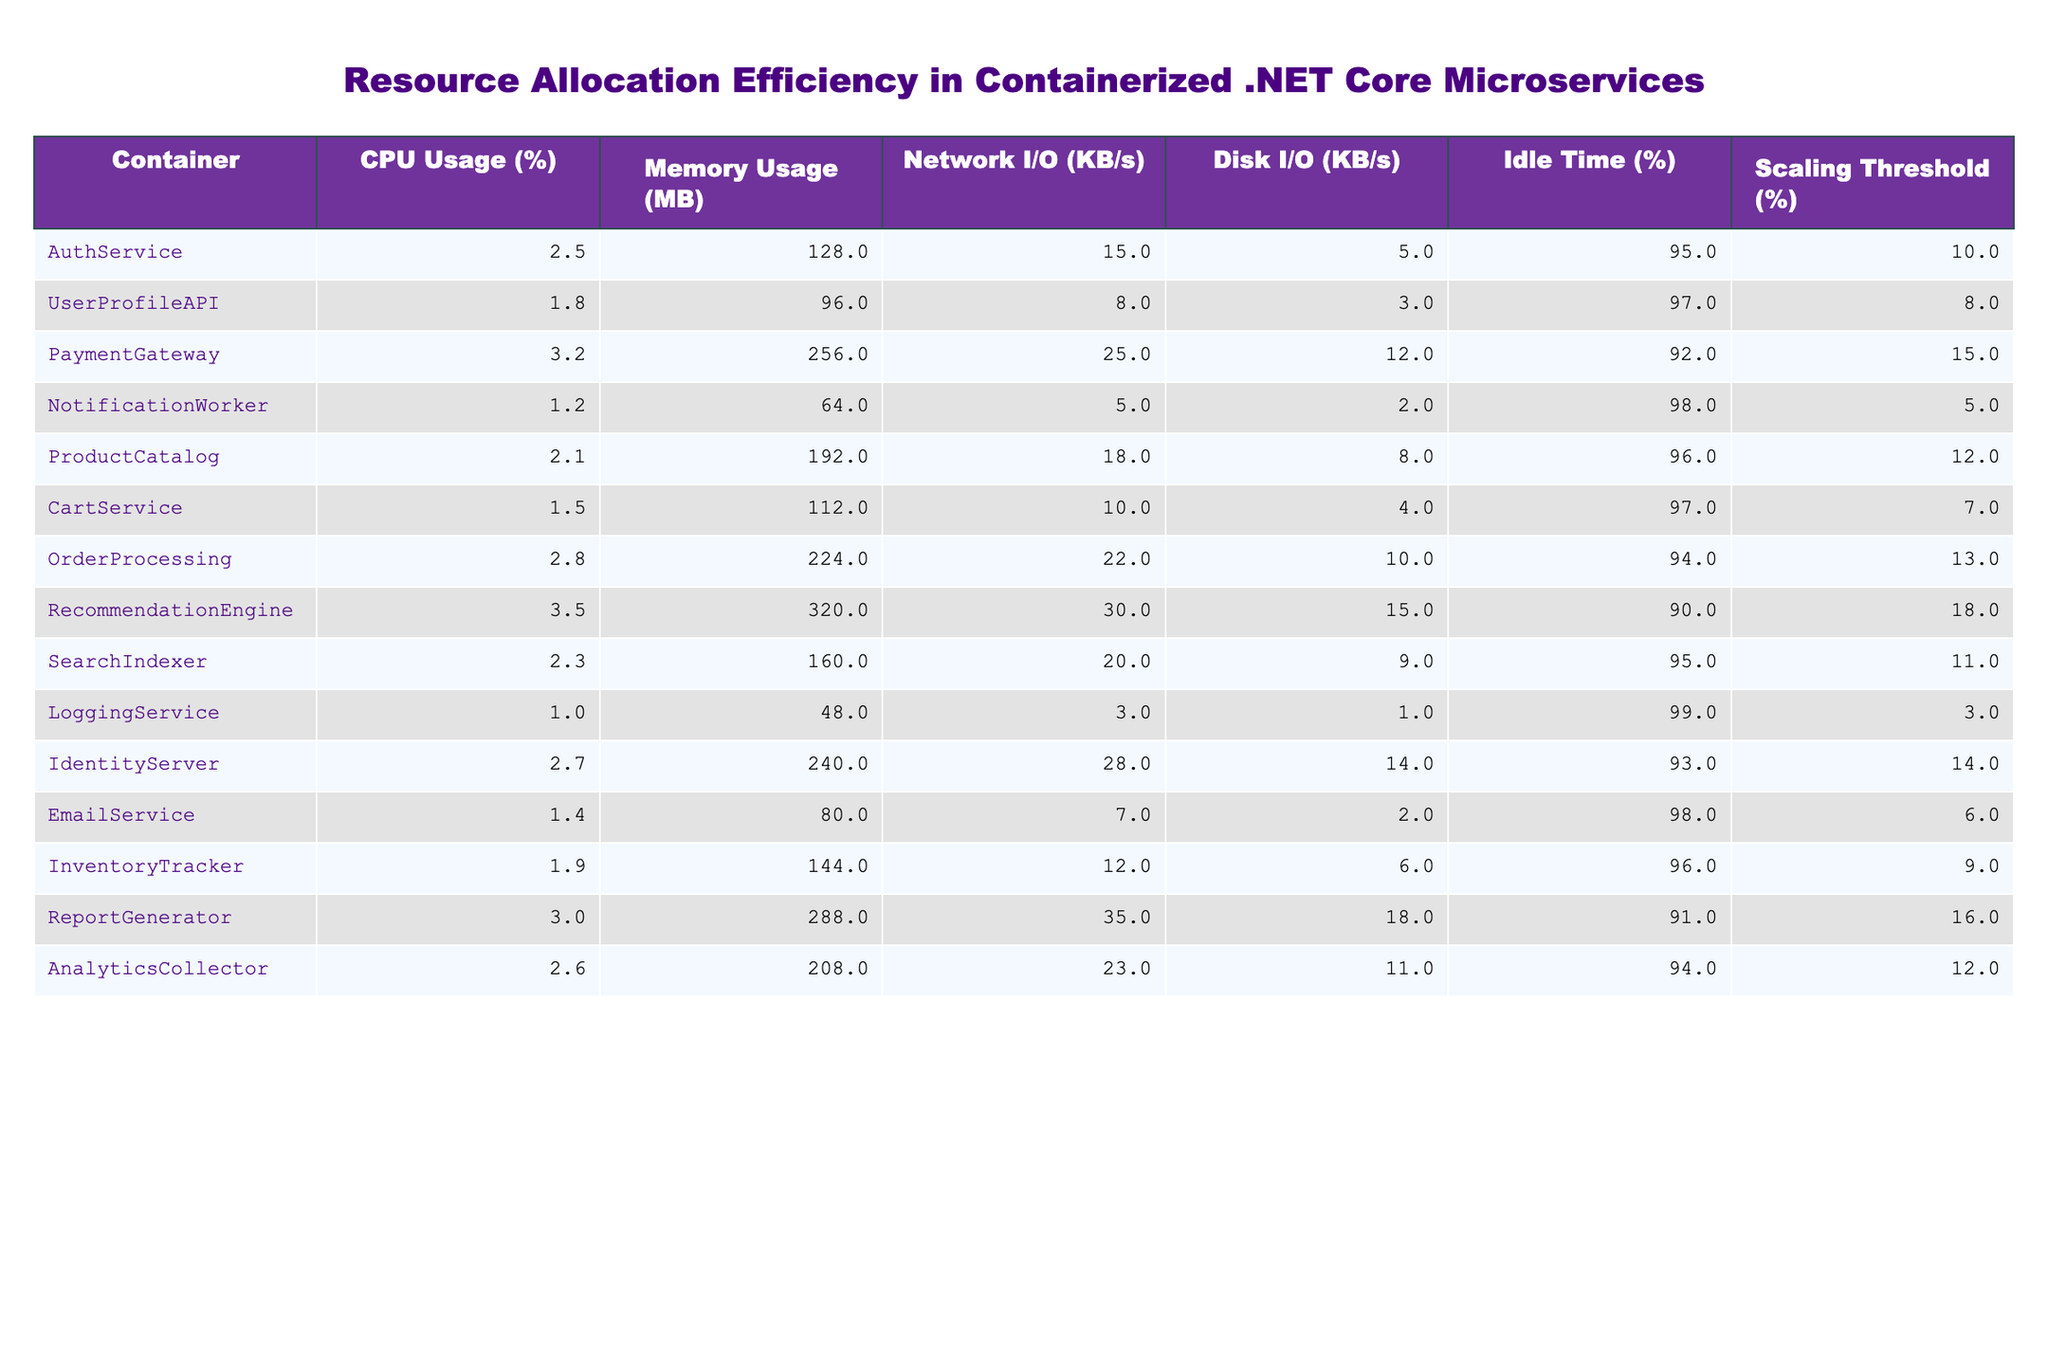What is the CPU usage of the Logging Service? The table shows that the CPU usage for the Logging Service is listed as 1.0%.
Answer: 1.0% Which container has the highest memory usage? By reviewing the Memory Usage column, the Recommendation Engine has the highest memory usage at 320 MB.
Answer: Recommendation Engine What is the average idle time across all containers? Adding the Idle Time values (95 + 97 + 92 + 98 + 96 + 97 + 94 + 90 + 95 + 99 + 93 + 98 + 96 + 91 + 94) gives a total of 1,416. There are 15 containers, so the average idle time is 1,416 / 15 = 94.4%.
Answer: 94.4% Is the CPU usage of the Payment Gateway greater than the Scaling Threshold? The Payment Gateway's CPU usage is 3.2%, while the Scaling Threshold is 15%. Since 3.2% is less than 15%, the answer is no.
Answer: No What is the difference in Disk I/O between the AuthService and the Notification Worker? The Disk I/O for AuthService is 5 KB/s and for the Notification Worker, it is 2 KB/s. The difference is 5 - 2 = 3 KB/s.
Answer: 3 KB/s How many containers have an Idle Time greater than 95%? The containers with Idle Time greater than 95% are AuthService, UserProfileAPI, NotificationWorker, EmailService, LoggingService, and InventoryTracker. This makes a total of 6 containers.
Answer: 6 What is the total Network I/O for the two services with the highest CPU usage? The two services with the highest CPU usage are the Recommendation Engine (30 KB/s) and the Payment Gateway (25 KB/s). Their total Network I/O is 30 + 25 = 55 KB/s.
Answer: 55 KB/s Is the Memory Usage of the Identity Server greater than the average Memory Usage of all the containers? To determine this, the Identity Server's Memory Usage (240 MB) is compared to the average of (128 + 96 + 256 + 64 + 192 + 112 + 224 + 320 + 160 + 48 + 240 + 80 + 144 + 288 + 208) / 15 = 170.4 MB. Since 240 MB is greater than 170.4 MB, the answer is yes.
Answer: Yes Calculate the total CPU usage of all services combined. The sum of all CPU usages is (2.5 + 1.8 + 3.2 + 1.2 + 2.1 + 1.5 + 2.8 + 3.5 + 2.3 + 1.0 + 2.7 + 1.4 + 1.9 + 3.0 + 2.6) = 30.0%.
Answer: 30.0% Which service has the lowest Scaling Threshold percentage? By examining the Scaling Threshold column, NotificationWorker has the lowest value at 5%.
Answer: NotificationWorker 